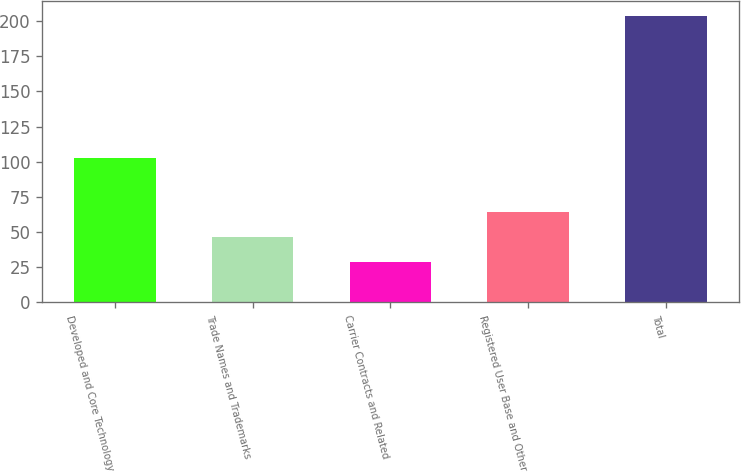<chart> <loc_0><loc_0><loc_500><loc_500><bar_chart><fcel>Developed and Core Technology<fcel>Trade Names and Trademarks<fcel>Carrier Contracts and Related<fcel>Registered User Base and Other<fcel>Total<nl><fcel>103<fcel>46.5<fcel>29<fcel>64<fcel>204<nl></chart> 